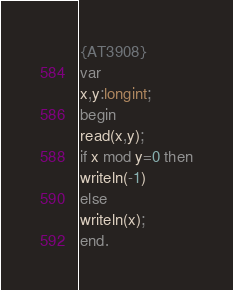Convert code to text. <code><loc_0><loc_0><loc_500><loc_500><_Pascal_>{AT3908}
var
x,y:longint;
begin
read(x,y);
if x mod y=0 then
writeln(-1)
else
writeln(x);
end.</code> 